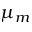<formula> <loc_0><loc_0><loc_500><loc_500>\mu _ { m }</formula> 